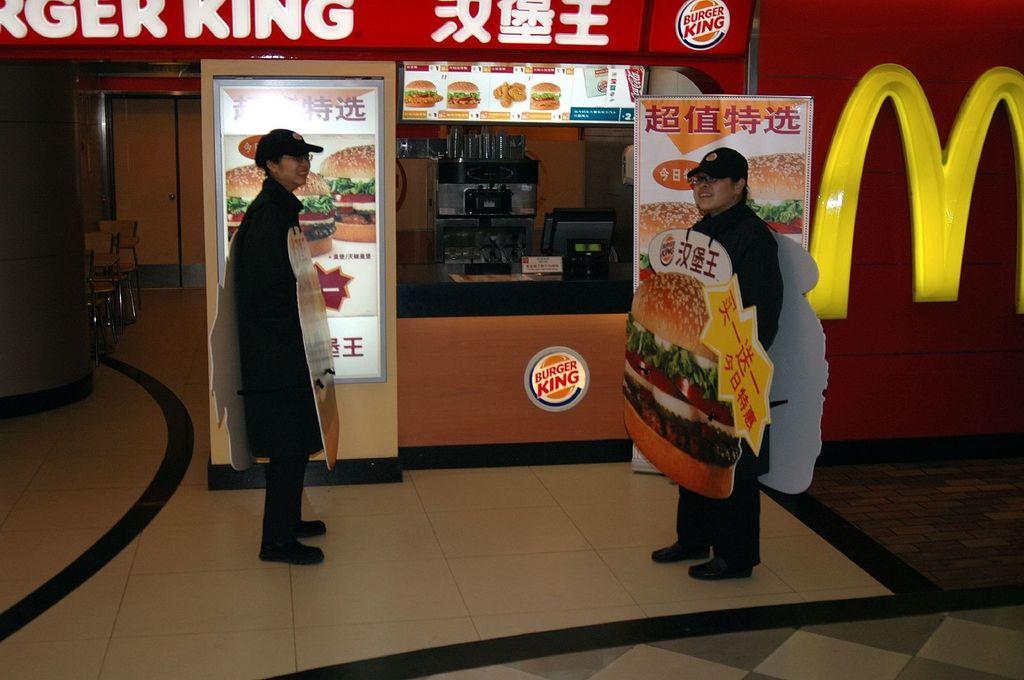Can you describe this image briefly? In this image we can see two persons standing on a surface wearing some objects on them. Behind the persons we can see two hoardings and a store with a counter table. On the right side of the image we can see a wall and on the left side, we can see a pillar and a few chairs. At the top we can see some text and on the counter table there are some objects. Behind the counter table there are few objects. 